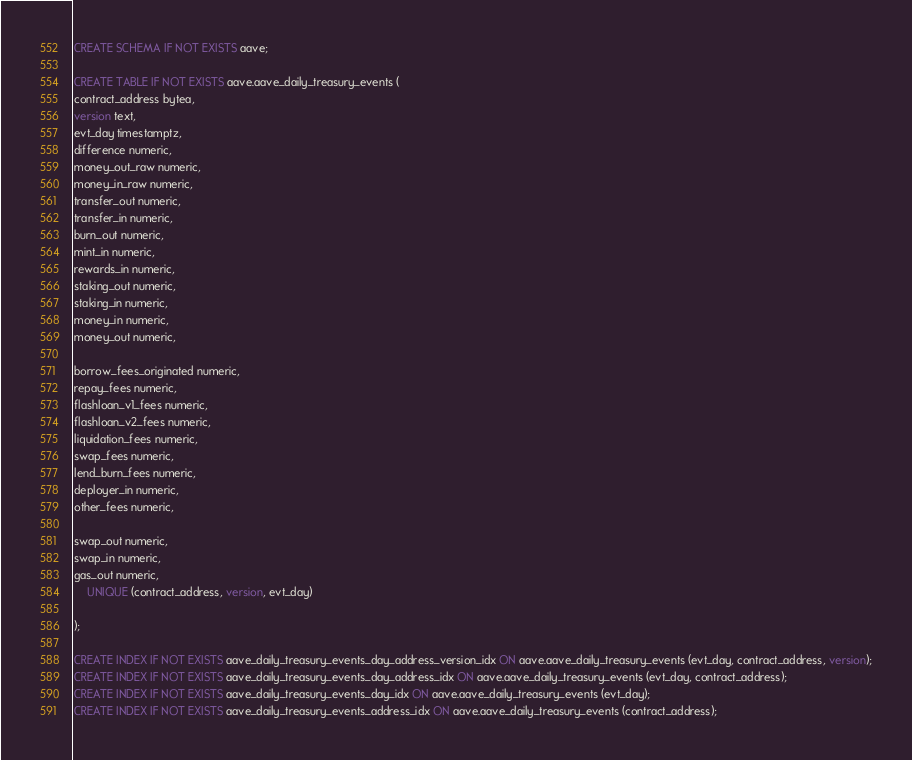<code> <loc_0><loc_0><loc_500><loc_500><_SQL_>CREATE SCHEMA IF NOT EXISTS aave;

CREATE TABLE IF NOT EXISTS aave.aave_daily_treasury_events (
contract_address bytea,
version text,
evt_day timestamptz,
difference numeric,
money_out_raw numeric,
money_in_raw numeric,
transfer_out numeric,
transfer_in numeric,
burn_out numeric,
mint_in numeric,
rewards_in numeric,
staking_out numeric,
staking_in numeric,
money_in numeric,
money_out numeric,

borrow_fees_originated numeric,
repay_fees numeric,
flashloan_v1_fees numeric,
flashloan_v2_fees numeric,
liquidation_fees numeric,
swap_fees numeric,
lend_burn_fees numeric,
deployer_in numeric,
other_fees numeric,

swap_out numeric,
swap_in numeric,
gas_out numeric,
	UNIQUE (contract_address, version, evt_day)

);

CREATE INDEX IF NOT EXISTS aave_daily_treasury_events_day_address_version_idx ON aave.aave_daily_treasury_events (evt_day, contract_address, version);
CREATE INDEX IF NOT EXISTS aave_daily_treasury_events_day_address_idx ON aave.aave_daily_treasury_events (evt_day, contract_address);
CREATE INDEX IF NOT EXISTS aave_daily_treasury_events_day_idx ON aave.aave_daily_treasury_events (evt_day);
CREATE INDEX IF NOT EXISTS aave_daily_treasury_events_address_idx ON aave.aave_daily_treasury_events (contract_address);
</code> 